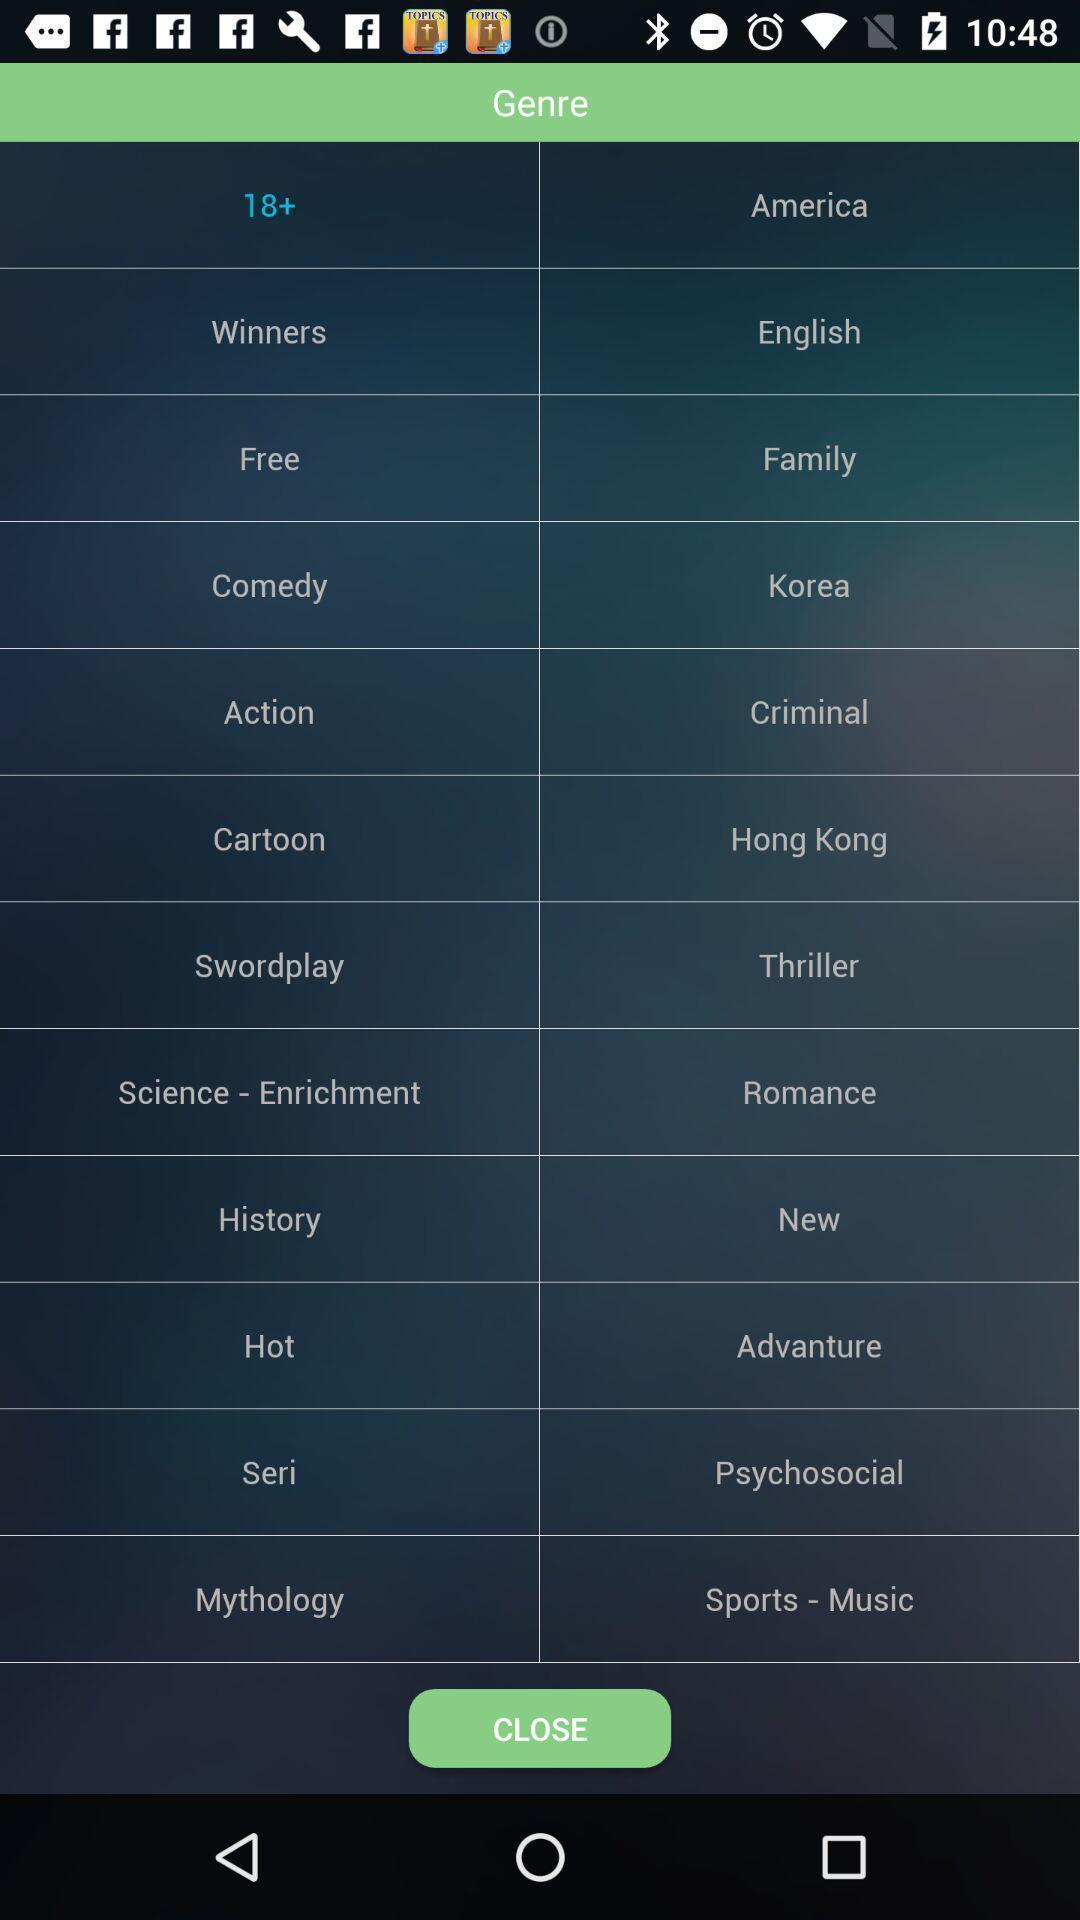Please provide a description for this image. Page displaying list of genres. 